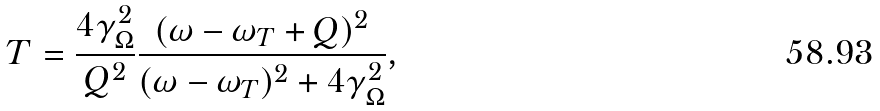Convert formula to latex. <formula><loc_0><loc_0><loc_500><loc_500>T = \frac { 4 \gamma _ { \Omega } ^ { 2 } } { Q ^ { 2 } } \frac { ( \omega - \omega _ { T } + Q ) ^ { 2 } } { ( \omega - \omega _ { T } ) ^ { 2 } + 4 \gamma ^ { 2 } _ { \Omega } } ,</formula> 